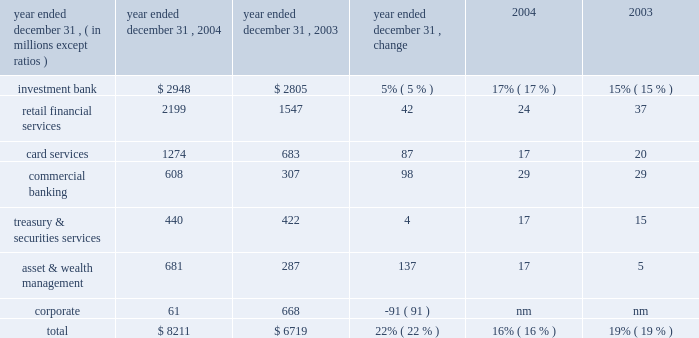Jpmorgan chase & co .
/ 2004 annual report 29 firms were aligned to provide consistency across the business segments .
In addition , expenses related to certain corporate functions , technology and operations ceased to be allocated to the business segments and are retained in corporate .
These retained expenses include parent company costs that would not be incurred if the segments were stand-alone businesses ; adjustments to align certain corporate staff , technology and operations allocations with market prices ; and other one-time items not aligned with the business segments .
Capital allocation each business segment is allocated capital by taking into consideration stand- alone peer comparisons , economic risk measures and regulatory capital requirements .
The amount of capital assigned to each business is referred to as equity .
Effective with the third quarter of 2004 , new methodologies were implemented to calculate the amount of capital allocated to each segment .
As part of the new methodology , goodwill , as well as the associated capital , is allocated solely to corporate .
Although u.s .
Gaap requires the allocation of goodwill to the business segments for impairment testing ( see note 15 on page 109 of this annual report ) , the firm has elected not to include goodwill or the related capital in each of the business segments for management reporting purposes .
See the capital management section on page 50 of this annual report for a discussion of the equity framework .
Credit reimbursement tss reimburses the ib for credit portfolio exposures the ib manages on behalf of clients the segments share .
At the time of the merger , the reimbursement methodology was revised to be based on pre-tax earnings , net of the cost of capital related to those exposures .
Prior to the merger , the credit reimburse- ment was based on pre-tax earnings , plus the allocated capital associated with the shared clients .
Tax-equivalent adjustments segment results reflect revenues on a tax-equivalent basis for segment reporting purposes .
Refer to page 25 of this annual report for additional details .
Description of business segment reporting methodology results of the business segments are intended to reflect each segment as if it were essentially a stand-alone business .
The management reporting process that derives these results allocates income and expense using market-based methodologies .
At the time of the merger , several of the allocation method- ologies were revised , as noted below .
The changes became effective july 1 , 2004 .
As prior periods have not been revised to reflect these new methodologies , they are not comparable to the presentation of periods begin- ning with the third quarter of 2004 .
Further , the firm intends to continue to assess the assumptions , methodologies and reporting reclassifications used for segment reporting , and it is anticipated that further refinements may be implemented in future periods .
Revenue sharing when business segments join efforts to sell products and services to the firm 2019s clients , the participating business segments agree to share revenues from those transactions .
These revenue sharing agreements were revised on the merger date to provide consistency across the lines of businesses .
Funds transfer pricing funds transfer pricing ( 201cftp 201d ) is used to allocate interest income and interest expense to each line of business and also serves to transfer interest rate risk to corporate .
While business segments may periodically retain interest rate exposures related to customer pricing or other business-specific risks , the bal- ance of the firm 2019s overall interest rate risk exposure is included and managed in corporate .
In the third quarter of 2004 , ftp was revised to conform the policies of the combined firms .
Expense allocation where business segments use services provided by support units within the firm , the costs of those support units are allocated to the business segments .
Those expenses are allocated based on their actual cost , or the lower of actual cost or market cost , as well as upon usage of the services provided .
Effective with the third quarter of 2004 , the cost allocation methodologies of the heritage segment results 2013 operating basis ( a ) ( b ) ( table continued from previous page ) year ended december 31 , operating earnings return on common equity 2013 goodwill ( c ) .

In 2004 , what percent of operating earnings were allocated to commercial banking? 
Computations: (608 / 8211)
Answer: 0.07405. 